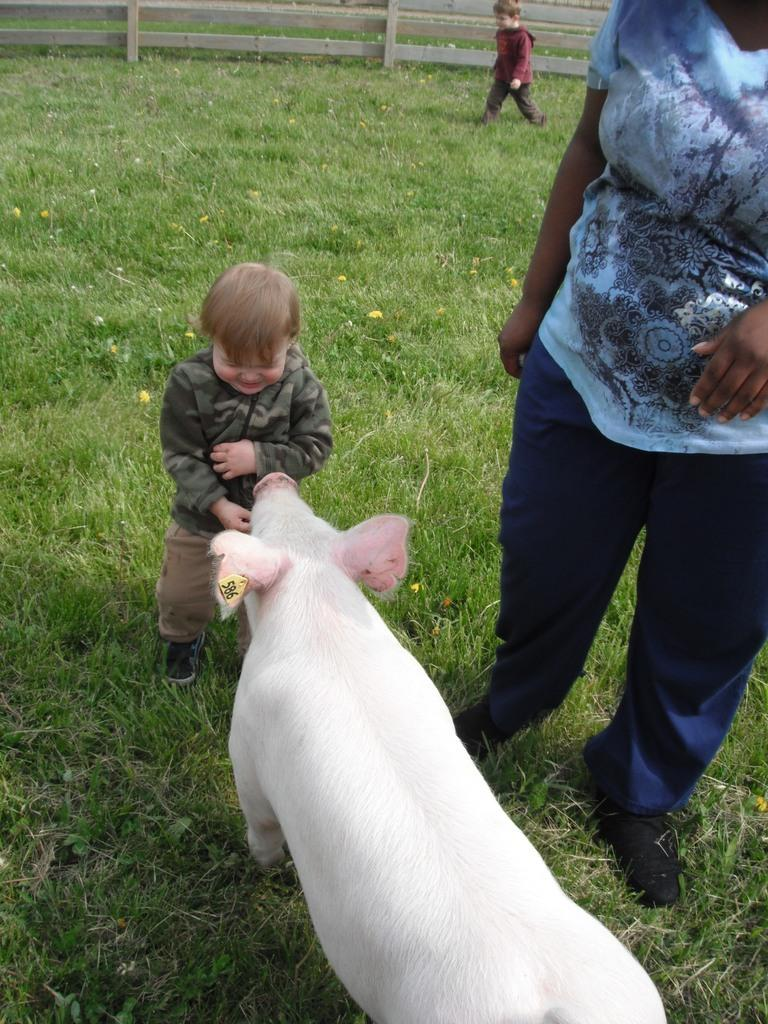Who is present in the image? There is a woman and two children in the image. What are the woman and children doing in the image? The woman and children are standing on the ground. What type of vegetation can be seen in the image? There is grass and plants with flowers visible in the image. What is in the background of the image? There is a wooden fence in the background of the image. What type of flower is the woman holding in the image? There is no flower visible in the woman's hand in the image. Can you see any cracks in the wooden fence in the background? The image does not provide enough detail to determine if there are any cracks in the wooden fence. What is the woman doing in the picture? The woman is standing on the ground with two children, as mentioned in the conversation. 